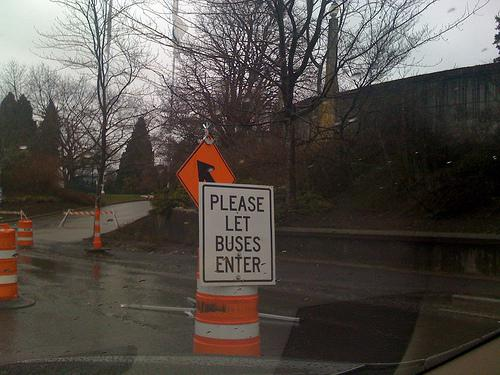Question: what does the white sign say?
Choices:
A. Please Let Buses Enter.
B. Stop ahead.
C. One way.
D. No turn on red.
Answer with the letter. Answer: A Question: what shape is the orange sign?
Choices:
A. Octagonal.
B. Round.
C. Square.
D. Diamond.
Answer with the letter. Answer: D Question: how many construction barrels are there?
Choices:
A. 3.
B. 6.
C. 7.
D. 2.
Answer with the letter. Answer: A Question: how many construction workers are present?
Choices:
A. 6.
B. None.
C. 3.
D. 2.
Answer with the letter. Answer: B Question: how many construction barricades are shown?
Choices:
A. 4.
B. 6.
C. 7.
D. 2.
Answer with the letter. Answer: D Question: where are the construction barricades?
Choices:
A. In front of the bulldozer.
B. Blocking the manhole.
C. Blocking the end of the side street located on the left.
D. In front of the building.
Answer with the letter. Answer: C Question: what objects are orange and white?
Choices:
A. The pickup truck.
B. The construction barrels, barricades, and cone.
C. The workers' vests.
D. The caution tape.
Answer with the letter. Answer: B 